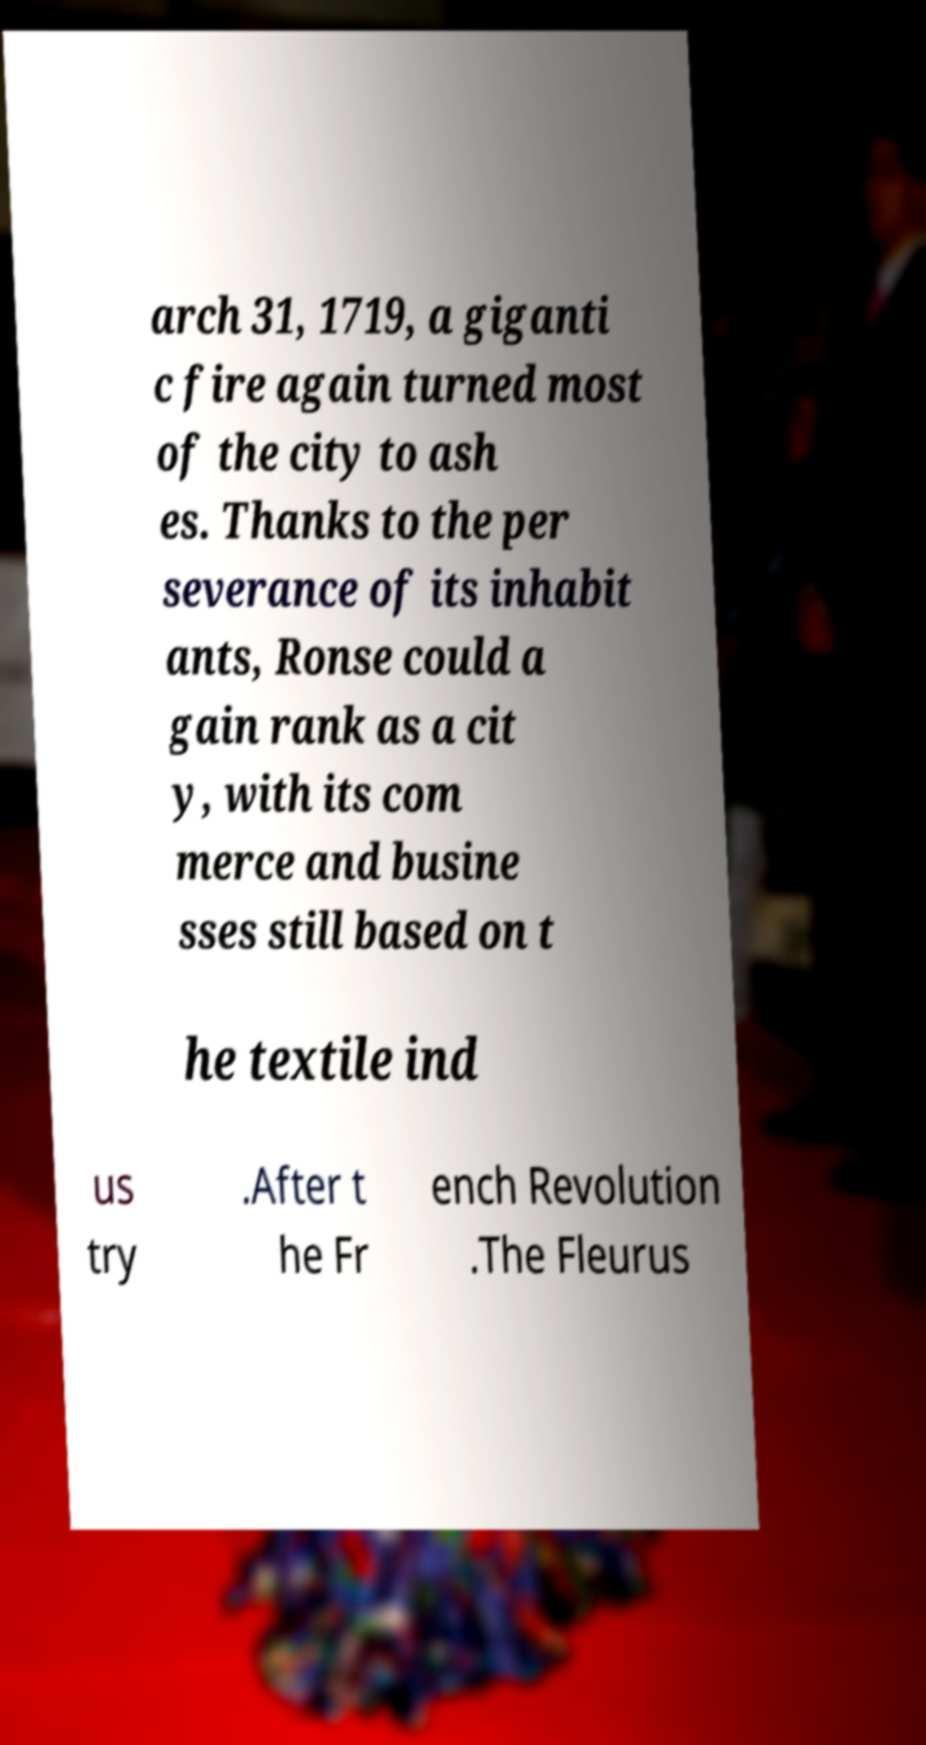Can you read and provide the text displayed in the image?This photo seems to have some interesting text. Can you extract and type it out for me? arch 31, 1719, a giganti c fire again turned most of the city to ash es. Thanks to the per severance of its inhabit ants, Ronse could a gain rank as a cit y, with its com merce and busine sses still based on t he textile ind us try .After t he Fr ench Revolution .The Fleurus 